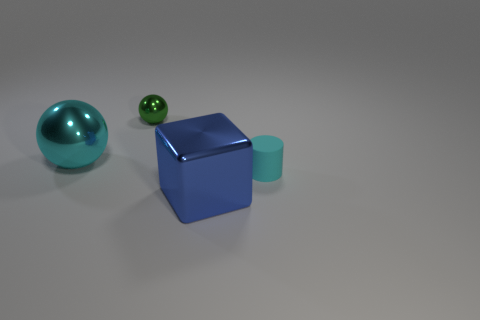What textures are visible on the objects? The objects have a smooth and matte finish, with no discernible texture. The surfaces exhibit subtle reflections, suggesting they might be made of plastic or a similar material. 